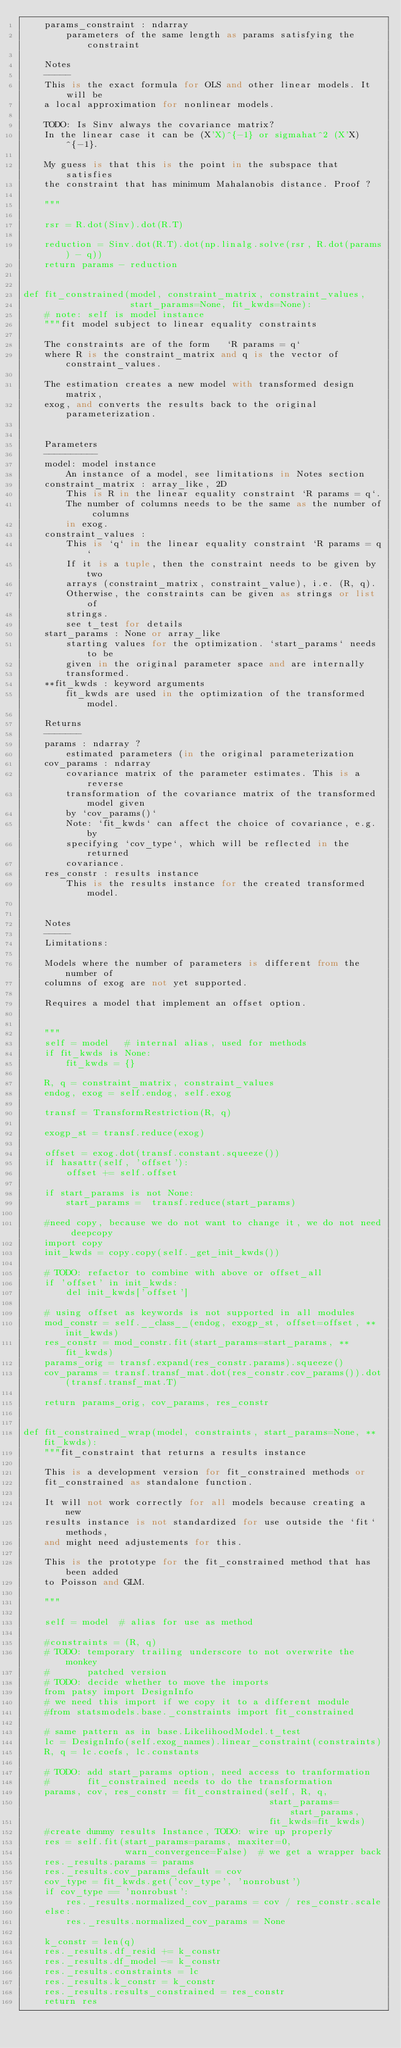Convert code to text. <code><loc_0><loc_0><loc_500><loc_500><_Python_>    params_constraint : ndarray
        parameters of the same length as params satisfying the constraint

    Notes
    -----
    This is the exact formula for OLS and other linear models. It will be
    a local approximation for nonlinear models.

    TODO: Is Sinv always the covariance matrix?
    In the linear case it can be (X'X)^{-1} or sigmahat^2 (X'X)^{-1}.

    My guess is that this is the point in the subspace that satisfies
    the constraint that has minimum Mahalanobis distance. Proof ?

    """

    rsr = R.dot(Sinv).dot(R.T)

    reduction = Sinv.dot(R.T).dot(np.linalg.solve(rsr, R.dot(params) - q))
    return params - reduction


def fit_constrained(model, constraint_matrix, constraint_values,
                    start_params=None, fit_kwds=None):
    # note: self is model instance
    """fit model subject to linear equality constraints

    The constraints are of the form   `R params = q`
    where R is the constraint_matrix and q is the vector of constraint_values.

    The estimation creates a new model with transformed design matrix,
    exog, and converts the results back to the original parameterization.


    Parameters
    ----------
    model: model instance
        An instance of a model, see limitations in Notes section
    constraint_matrix : array_like, 2D
        This is R in the linear equality constraint `R params = q`.
        The number of columns needs to be the same as the number of columns
        in exog.
    constraint_values :
        This is `q` in the linear equality constraint `R params = q`
        If it is a tuple, then the constraint needs to be given by two
        arrays (constraint_matrix, constraint_value), i.e. (R, q).
        Otherwise, the constraints can be given as strings or list of
        strings.
        see t_test for details
    start_params : None or array_like
        starting values for the optimization. `start_params` needs to be
        given in the original parameter space and are internally
        transformed.
    **fit_kwds : keyword arguments
        fit_kwds are used in the optimization of the transformed model.

    Returns
    -------
    params : ndarray ?
        estimated parameters (in the original parameterization
    cov_params : ndarray
        covariance matrix of the parameter estimates. This is a reverse
        transformation of the covariance matrix of the transformed model given
        by `cov_params()`
        Note: `fit_kwds` can affect the choice of covariance, e.g. by
        specifying `cov_type`, which will be reflected in the returned
        covariance.
    res_constr : results instance
        This is the results instance for the created transformed model.


    Notes
    -----
    Limitations:

    Models where the number of parameters is different from the number of
    columns of exog are not yet supported.

    Requires a model that implement an offset option.


    """
    self = model   # internal alias, used for methods
    if fit_kwds is None:
        fit_kwds = {}

    R, q = constraint_matrix, constraint_values
    endog, exog = self.endog, self.exog

    transf = TransformRestriction(R, q)

    exogp_st = transf.reduce(exog)

    offset = exog.dot(transf.constant.squeeze())
    if hasattr(self, 'offset'):
        offset += self.offset

    if start_params is not None:
        start_params =  transf.reduce(start_params)

    #need copy, because we do not want to change it, we do not need deepcopy
    import copy
    init_kwds = copy.copy(self._get_init_kwds())

    # TODO: refactor to combine with above or offset_all
    if 'offset' in init_kwds:
        del init_kwds['offset']

    # using offset as keywords is not supported in all modules
    mod_constr = self.__class__(endog, exogp_st, offset=offset, **init_kwds)
    res_constr = mod_constr.fit(start_params=start_params, **fit_kwds)
    params_orig = transf.expand(res_constr.params).squeeze()
    cov_params = transf.transf_mat.dot(res_constr.cov_params()).dot(transf.transf_mat.T)

    return params_orig, cov_params, res_constr


def fit_constrained_wrap(model, constraints, start_params=None, **fit_kwds):
    """fit_constraint that returns a results instance

    This is a development version for fit_constrained methods or
    fit_constrained as standalone function.

    It will not work correctly for all models because creating a new
    results instance is not standardized for use outside the `fit` methods,
    and might need adjustements for this.

    This is the prototype for the fit_constrained method that has been added
    to Poisson and GLM.

    """

    self = model  # alias for use as method

    #constraints = (R, q)
    # TODO: temporary trailing underscore to not overwrite the monkey
    #       patched version
    # TODO: decide whether to move the imports
    from patsy import DesignInfo
    # we need this import if we copy it to a different module
    #from statsmodels.base._constraints import fit_constrained

    # same pattern as in base.LikelihoodModel.t_test
    lc = DesignInfo(self.exog_names).linear_constraint(constraints)
    R, q = lc.coefs, lc.constants

    # TODO: add start_params option, need access to tranformation
    #       fit_constrained needs to do the transformation
    params, cov, res_constr = fit_constrained(self, R, q,
                                              start_params=start_params,
                                              fit_kwds=fit_kwds)
    #create dummy results Instance, TODO: wire up properly
    res = self.fit(start_params=params, maxiter=0,
                   warn_convergence=False)  # we get a wrapper back
    res._results.params = params
    res._results.cov_params_default = cov
    cov_type = fit_kwds.get('cov_type', 'nonrobust')
    if cov_type == 'nonrobust':
        res._results.normalized_cov_params = cov / res_constr.scale
    else:
        res._results.normalized_cov_params = None

    k_constr = len(q)
    res._results.df_resid += k_constr
    res._results.df_model -= k_constr
    res._results.constraints = lc
    res._results.k_constr = k_constr
    res._results.results_constrained = res_constr
    return res
</code> 